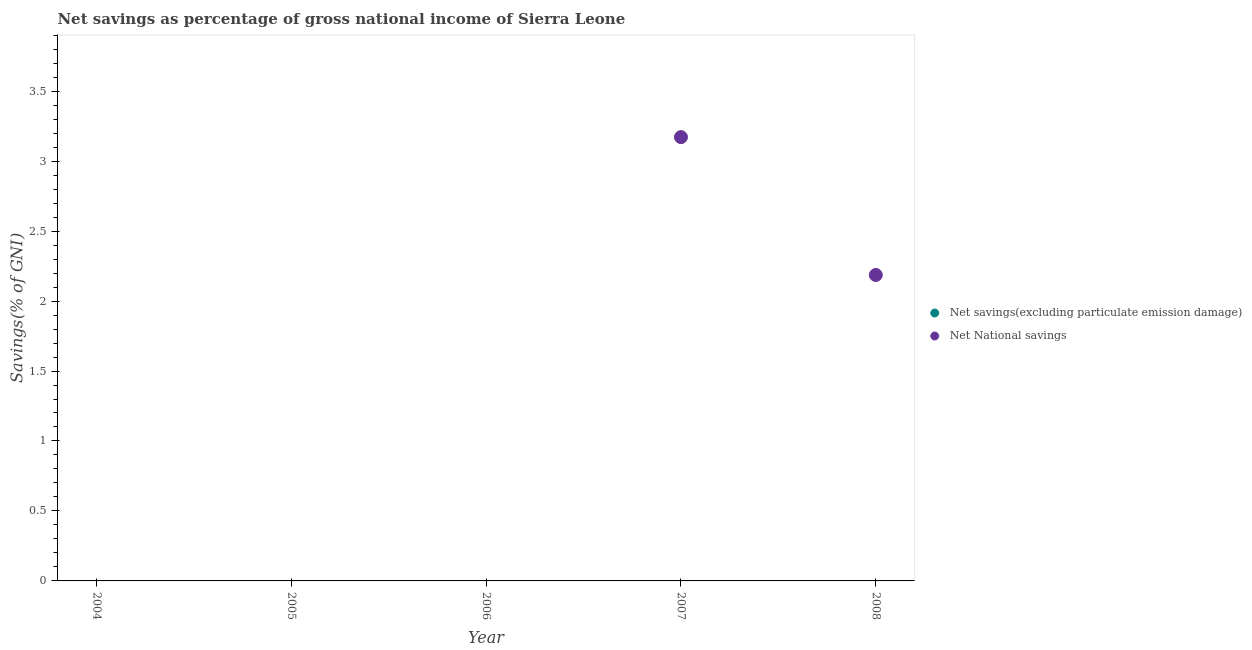How many different coloured dotlines are there?
Ensure brevity in your answer.  1. Is the number of dotlines equal to the number of legend labels?
Your answer should be compact. No. What is the net savings(excluding particulate emission damage) in 2005?
Your response must be concise. 0. Across all years, what is the maximum net national savings?
Give a very brief answer. 3.17. In which year was the net national savings maximum?
Make the answer very short. 2007. What is the total net national savings in the graph?
Ensure brevity in your answer.  5.36. What is the difference between the net national savings in 2007 and that in 2008?
Give a very brief answer. 0.99. What is the average net national savings per year?
Provide a short and direct response. 1.07. What is the difference between the highest and the lowest net national savings?
Your response must be concise. 3.17. In how many years, is the net savings(excluding particulate emission damage) greater than the average net savings(excluding particulate emission damage) taken over all years?
Give a very brief answer. 0. Does the net national savings monotonically increase over the years?
Provide a succinct answer. No. How many dotlines are there?
Keep it short and to the point. 1. What is the difference between two consecutive major ticks on the Y-axis?
Provide a short and direct response. 0.5. Are the values on the major ticks of Y-axis written in scientific E-notation?
Ensure brevity in your answer.  No. Does the graph contain any zero values?
Your response must be concise. Yes. Does the graph contain grids?
Your response must be concise. No. Where does the legend appear in the graph?
Offer a terse response. Center right. How are the legend labels stacked?
Your response must be concise. Vertical. What is the title of the graph?
Provide a succinct answer. Net savings as percentage of gross national income of Sierra Leone. What is the label or title of the X-axis?
Make the answer very short. Year. What is the label or title of the Y-axis?
Your response must be concise. Savings(% of GNI). What is the Savings(% of GNI) of Net National savings in 2005?
Make the answer very short. 0. What is the Savings(% of GNI) of Net savings(excluding particulate emission damage) in 2006?
Make the answer very short. 0. What is the Savings(% of GNI) in Net savings(excluding particulate emission damage) in 2007?
Give a very brief answer. 0. What is the Savings(% of GNI) in Net National savings in 2007?
Ensure brevity in your answer.  3.17. What is the Savings(% of GNI) in Net National savings in 2008?
Provide a short and direct response. 2.19. Across all years, what is the maximum Savings(% of GNI) in Net National savings?
Offer a very short reply. 3.17. What is the total Savings(% of GNI) of Net National savings in the graph?
Provide a succinct answer. 5.36. What is the difference between the Savings(% of GNI) in Net National savings in 2007 and that in 2008?
Your answer should be compact. 0.99. What is the average Savings(% of GNI) of Net savings(excluding particulate emission damage) per year?
Provide a short and direct response. 0. What is the average Savings(% of GNI) in Net National savings per year?
Your response must be concise. 1.07. What is the ratio of the Savings(% of GNI) of Net National savings in 2007 to that in 2008?
Provide a succinct answer. 1.45. What is the difference between the highest and the lowest Savings(% of GNI) in Net National savings?
Your response must be concise. 3.17. 